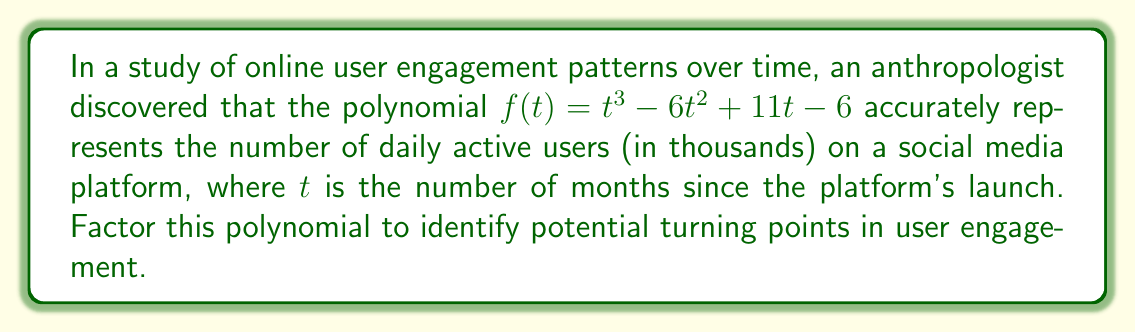Provide a solution to this math problem. To factor this polynomial, we'll follow these steps:

1) First, let's check if there are any rational roots using the rational root theorem. The possible rational roots are the factors of the constant term: ±1, ±2, ±3, ±6.

2) Testing these values, we find that $f(1) = 0$. So $(t-1)$ is a factor.

3) We can use polynomial long division to divide $f(t)$ by $(t-1)$:

   $$t^3 - 6t^2 + 11t - 6 = (t-1)(t^2 - 5t + 6)$$

4) Now we need to factor the quadratic term $t^2 - 5t + 6$. We can do this by finding two numbers that multiply to give 6 and add to give -5. These numbers are -2 and -3.

5) Therefore, $t^2 - 5t + 6 = (t-2)(t-3)$

6) Combining all factors, we get:

   $$f(t) = (t-1)(t-2)(t-3)$$

This factorization reveals that the polynomial has roots at $t=1$, $t=2$, and $t=3$, which could represent significant months in the platform's user engagement pattern.
Answer: $(t-1)(t-2)(t-3)$ 